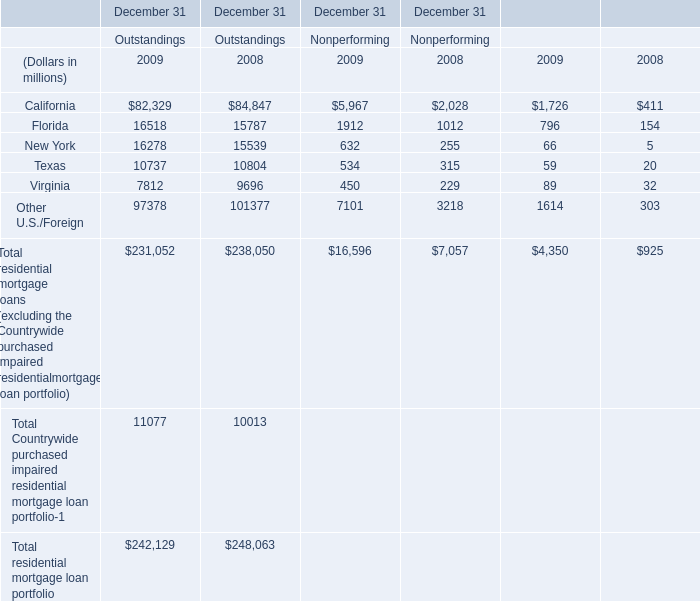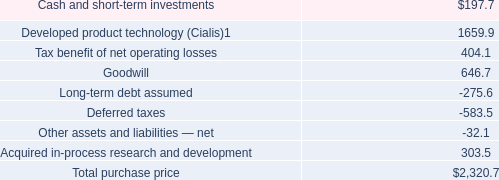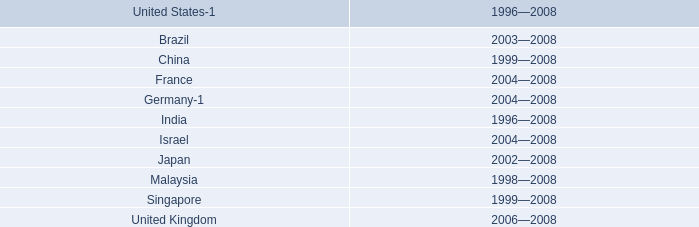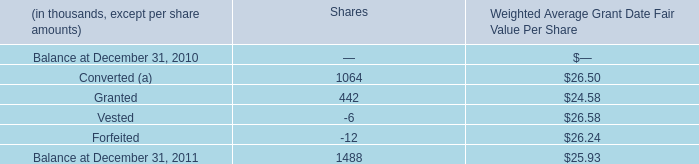Which year is the the Outstandings of total residential mortgage loan portfolio of Outstandings the highest? 
Answer: 2008. 